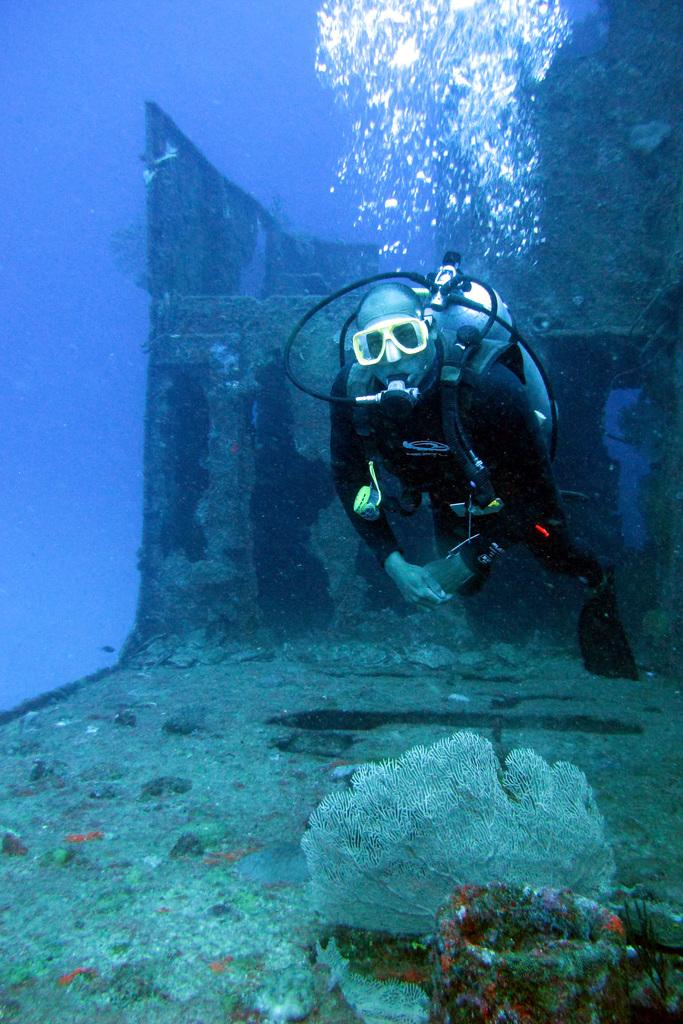What activity is the person in the image engaged in? The person in the image is doing scuba diving. What can be seen in the background of the image? There is a rock and coral reefs in the image. What is the smell of the town in the image? There is no town present in the image, so it is not possible to determine the smell. 